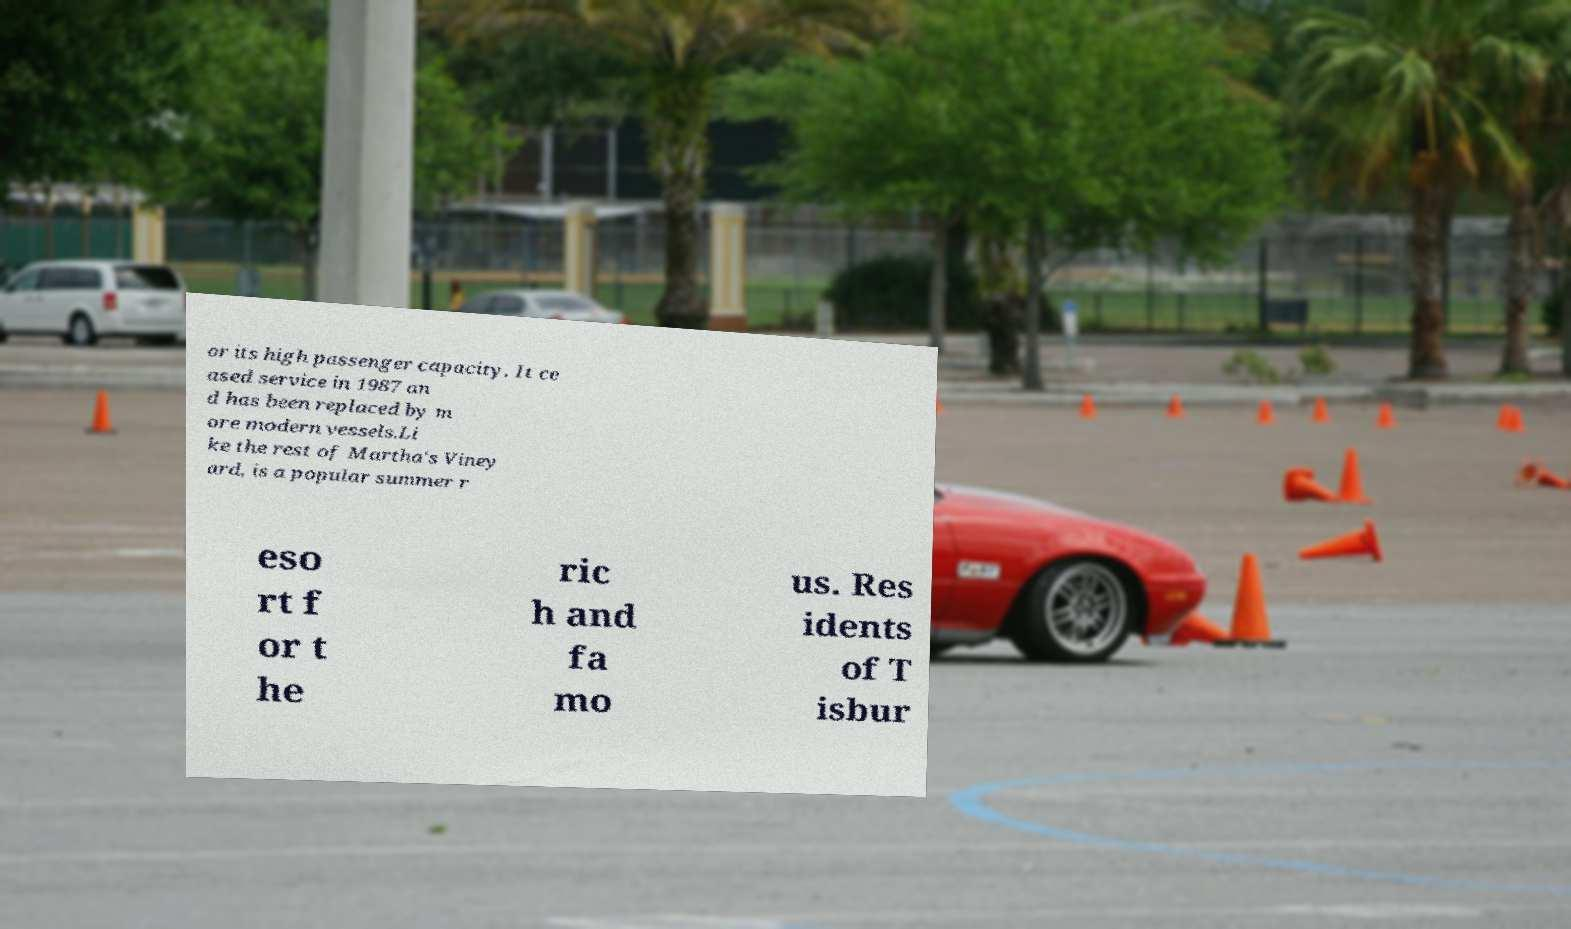I need the written content from this picture converted into text. Can you do that? or its high passenger capacity. It ce ased service in 1987 an d has been replaced by m ore modern vessels.Li ke the rest of Martha's Viney ard, is a popular summer r eso rt f or t he ric h and fa mo us. Res idents of T isbur 